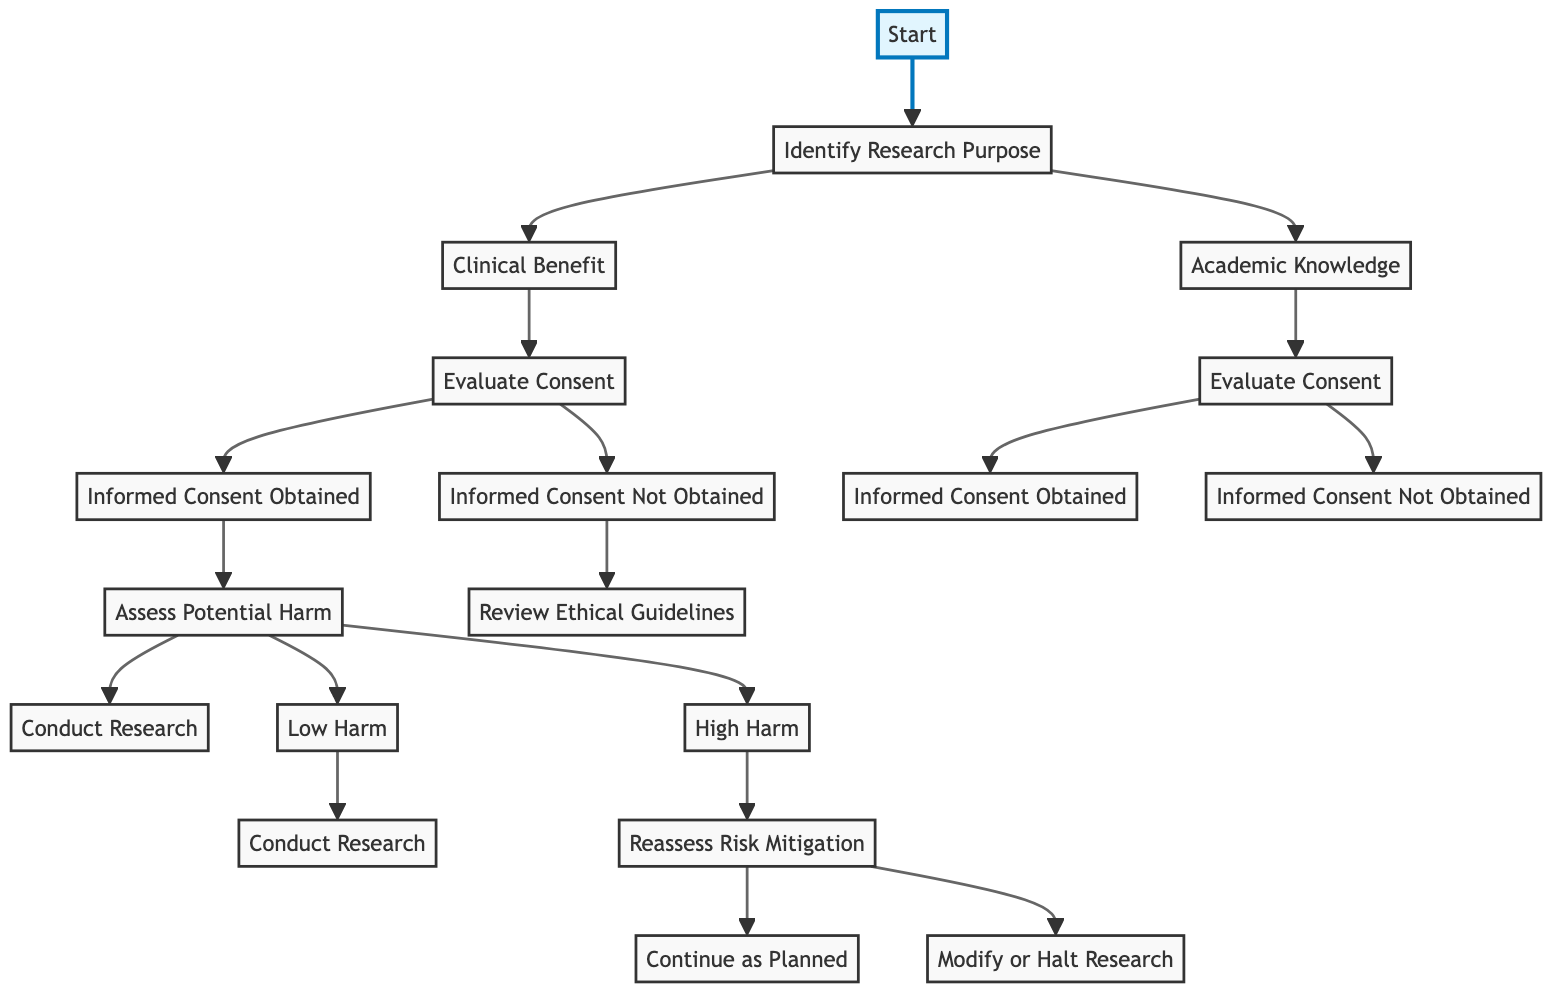What is the first step in the decision tree? The first step is labeled "Start," which is the entry point of the decision tree.
Answer: Start How many nodes are directly connected to the "Identify Research Purpose" node? There are two nodes connected to the "Identify Research Purpose" node, which are "Clinical Benefit" and "Academic Knowledge."
Answer: 2 What happens if informed consent is not obtained after evaluating consent from clinical benefit? If informed consent is not obtained, the flow leads to the "Review Ethical Guidelines" node, indicating a reconsideration of the ethical framework for the research.
Answer: Review Ethical Guidelines What are the possible outcomes after assessing potential harm if informed consent is obtained? The two outcomes after assessing potential harm are "Conduct Research" if the harm is low, and further evaluation based on the harm being high, leading to "Reassess Risk Mitigation."
Answer: Conduct Research, Reassess Risk Mitigation What node follows "High Harm" in the decision tree? The node that follows "High Harm" is "Reassess Risk Mitigation," indicating the need to evaluate the risks involved in the research further.
Answer: Reassess Risk Mitigation What is the final action taken if the potential harm is assessed to be low? If the potential harm is assessed to be low, the final action is to "Conduct Research," indicating that the study can proceed based on a low risk evaluation.
Answer: Conduct Research What happens after reassessing risk mitigation if it remains high? It leads to "Modify or Halt Research," suggesting that further action needs to be taken to reduce the risks involved.
Answer: Modify or Halt Research Which node represents a decision point regarding informed consent in the context of academic knowledge? The decision point in the context of academic knowledge regarding informed consent is found in the "Evaluate Consent" node connected to the "Academic Knowledge" pathway.
Answer: Evaluate Consent 